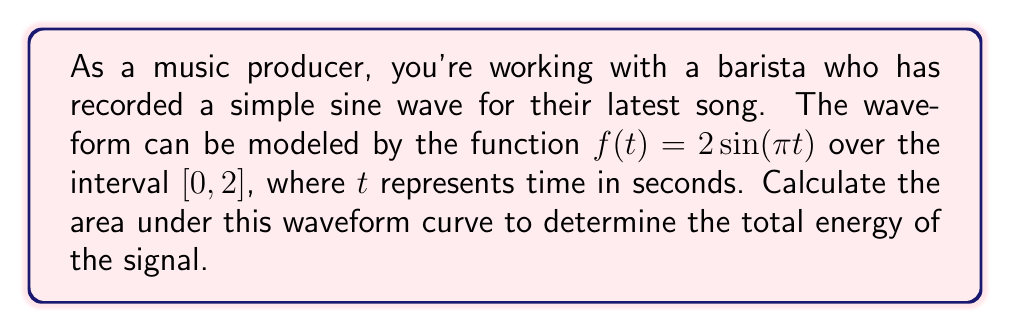Help me with this question. To find the area under the waveform curve, we need to calculate the definite integral of the function over the given interval. Let's approach this step-by-step:

1) The function is $f(t) = 2\sin(πt)$ and we need to integrate it from 0 to 2.

2) Set up the definite integral:
   $$\int_0^2 2\sin(πt) dt$$

3) To integrate this, we can use the substitution method:
   Let $u = πt$, then $du = π dt$ or $dt = \frac{1}{π} du$

4) When $t = 0$, $u = 0$
   When $t = 2$, $u = 2π$

5) Rewrite the integral in terms of $u$:
   $$\frac{2}{π} \int_0^{2π} \sin(u) du$$

6) The integral of sine is negative cosine:
   $$\frac{2}{π} [-\cos(u)]_0^{2π}$$

7) Evaluate the integral:
   $$\frac{2}{π} [-\cos(2π) + \cos(0)]$$

8) Simplify:
   $$\frac{2}{π} [-1 + 1] = 0$$

Therefore, the area under the waveform curve, which represents the total energy of the signal, is 0.
Answer: 0 